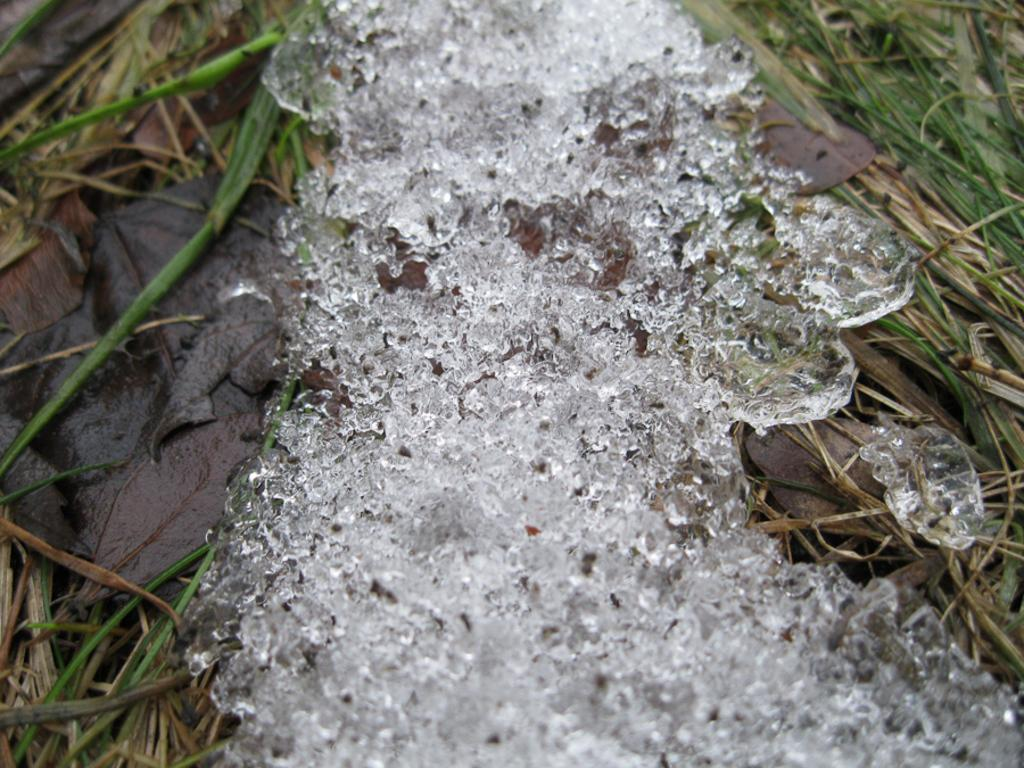What is the main subject in the center of the image? There is water in the center of the image. What type of vegetation can be seen in the background of the image? There is grass visible in the background of the image. How many pizzas are being held by the toy in the image? There is no toy or pizzas present in the image. 